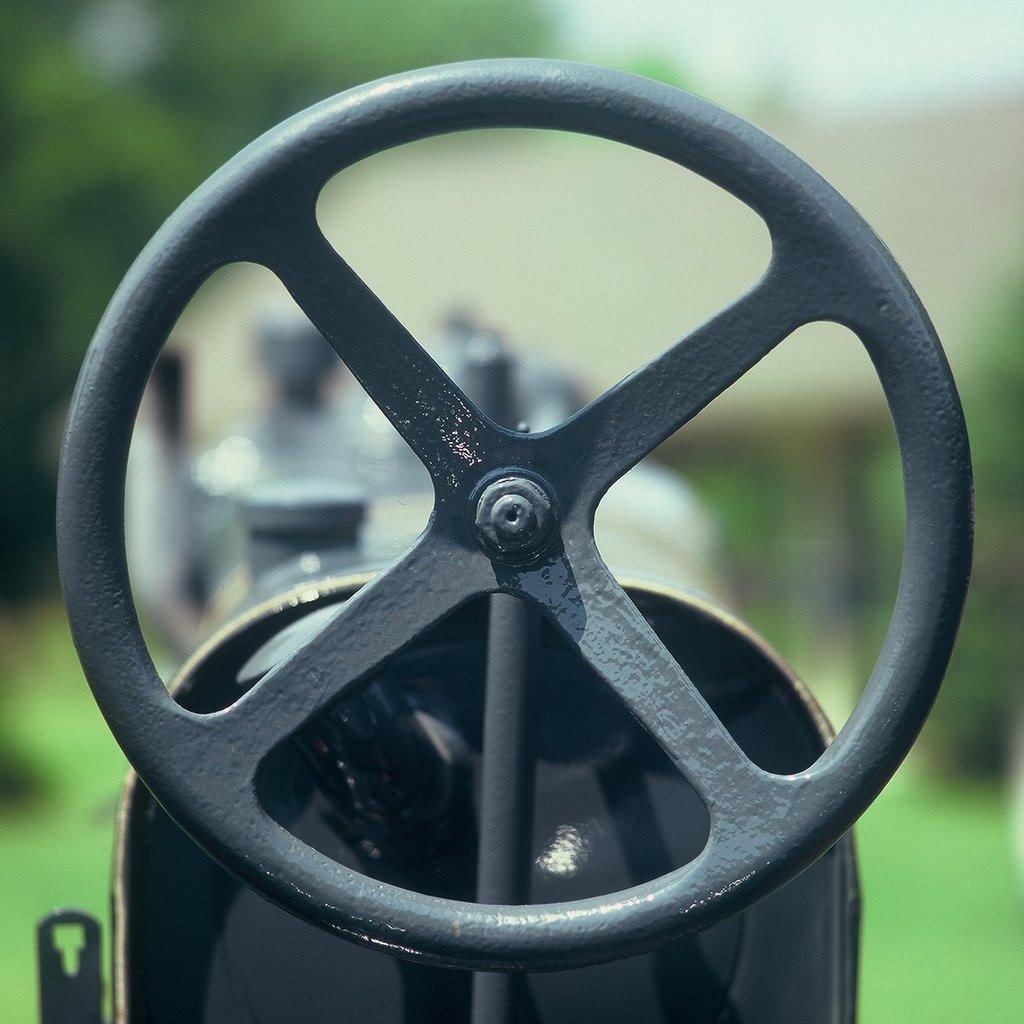Could you give a brief overview of what you see in this image? In this image, we can see a machine lever on the blur background. 